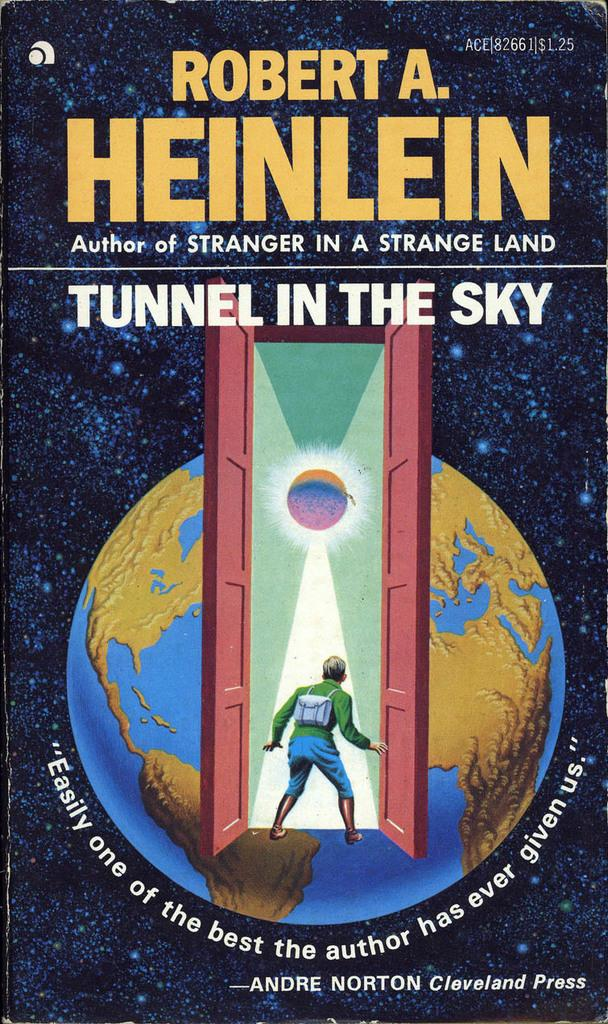<image>
Create a compact narrative representing the image presented. The cover of the book Tunnel in the sky by Robert Heinlein. 